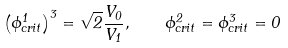Convert formula to latex. <formula><loc_0><loc_0><loc_500><loc_500>\left ( \phi ^ { 1 } _ { c r i t } \right ) ^ { 3 } = \sqrt { 2 } \frac { V _ { 0 } } { V _ { 1 } } , \quad \phi ^ { 2 } _ { c r i t } = \phi ^ { 3 } _ { c r i t } = 0</formula> 